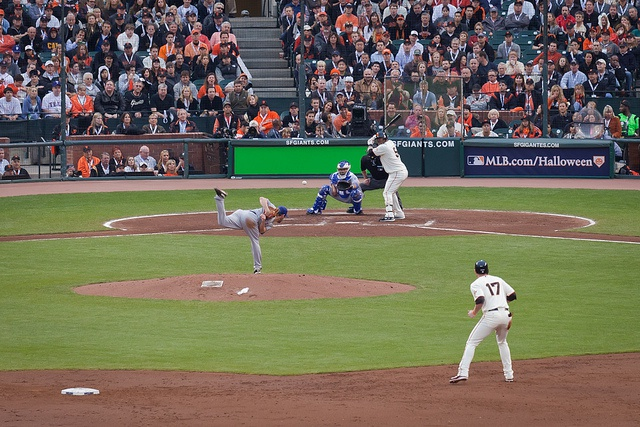Describe the objects in this image and their specific colors. I can see people in brown, black, gray, and darkgray tones, people in brown, lightgray, darkgray, olive, and gray tones, people in brown, darkgray, gray, and lavender tones, people in brown, lightgray, darkgray, gray, and black tones, and people in brown, navy, gray, and black tones in this image. 